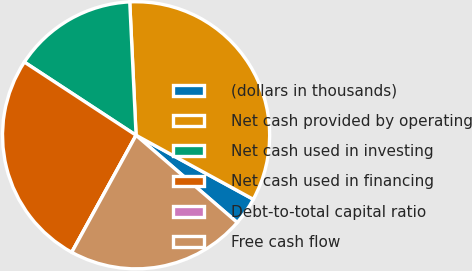Convert chart to OTSL. <chart><loc_0><loc_0><loc_500><loc_500><pie_chart><fcel>(dollars in thousands)<fcel>Net cash provided by operating<fcel>Net cash used in investing<fcel>Net cash used in financing<fcel>Debt-to-total capital ratio<fcel>Free cash flow<nl><fcel>3.37%<fcel>33.71%<fcel>15.01%<fcel>26.23%<fcel>0.0%<fcel>21.67%<nl></chart> 